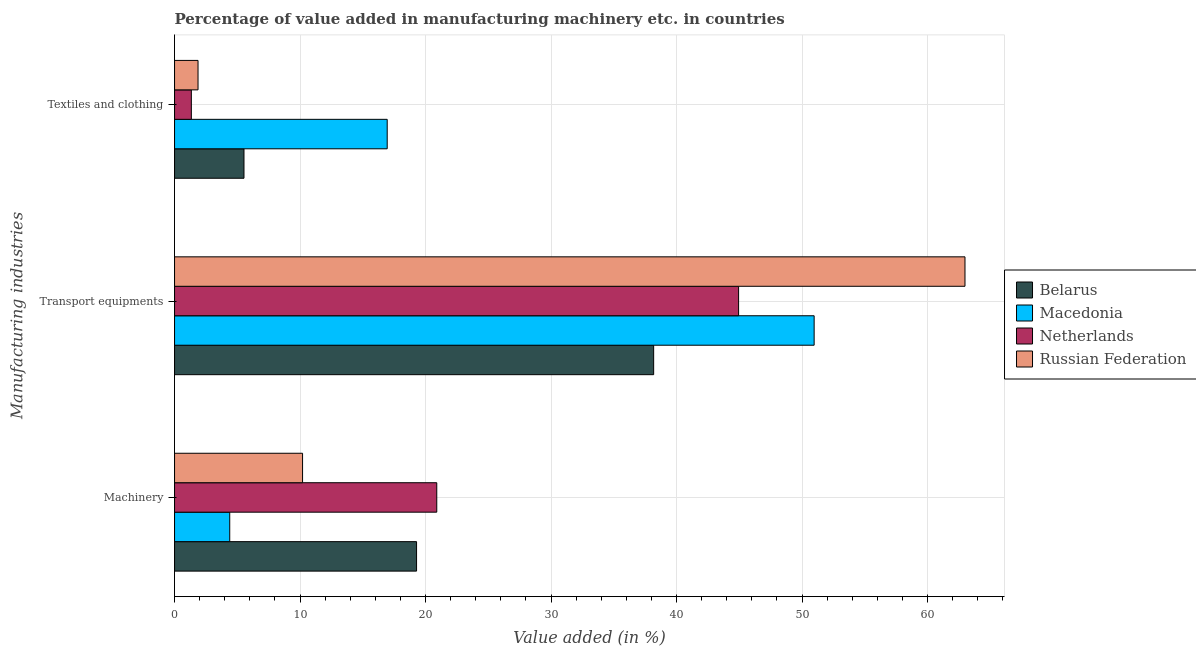How many groups of bars are there?
Your answer should be very brief. 3. Are the number of bars per tick equal to the number of legend labels?
Give a very brief answer. Yes. Are the number of bars on each tick of the Y-axis equal?
Your response must be concise. Yes. How many bars are there on the 1st tick from the top?
Provide a short and direct response. 4. What is the label of the 2nd group of bars from the top?
Offer a terse response. Transport equipments. What is the value added in manufacturing machinery in Netherlands?
Ensure brevity in your answer.  20.9. Across all countries, what is the maximum value added in manufacturing textile and clothing?
Make the answer very short. 16.95. Across all countries, what is the minimum value added in manufacturing textile and clothing?
Keep it short and to the point. 1.34. In which country was the value added in manufacturing transport equipments maximum?
Give a very brief answer. Russian Federation. In which country was the value added in manufacturing transport equipments minimum?
Your response must be concise. Belarus. What is the total value added in manufacturing transport equipments in the graph?
Provide a succinct answer. 197.08. What is the difference between the value added in manufacturing machinery in Belarus and that in Russian Federation?
Offer a very short reply. 9.08. What is the difference between the value added in manufacturing transport equipments in Belarus and the value added in manufacturing textile and clothing in Russian Federation?
Keep it short and to the point. 36.31. What is the average value added in manufacturing machinery per country?
Your answer should be compact. 13.7. What is the difference between the value added in manufacturing textile and clothing and value added in manufacturing machinery in Belarus?
Your answer should be very brief. -13.75. In how many countries, is the value added in manufacturing textile and clothing greater than 4 %?
Give a very brief answer. 2. What is the ratio of the value added in manufacturing textile and clothing in Macedonia to that in Russian Federation?
Your answer should be compact. 9.06. Is the value added in manufacturing machinery in Belarus less than that in Netherlands?
Keep it short and to the point. Yes. What is the difference between the highest and the second highest value added in manufacturing machinery?
Offer a very short reply. 1.61. What is the difference between the highest and the lowest value added in manufacturing transport equipments?
Provide a short and direct response. 24.81. In how many countries, is the value added in manufacturing transport equipments greater than the average value added in manufacturing transport equipments taken over all countries?
Offer a very short reply. 2. What does the 3rd bar from the top in Machinery represents?
Give a very brief answer. Macedonia. What does the 1st bar from the bottom in Textiles and clothing represents?
Provide a short and direct response. Belarus. Are all the bars in the graph horizontal?
Your answer should be very brief. Yes. Are the values on the major ticks of X-axis written in scientific E-notation?
Make the answer very short. No. Does the graph contain any zero values?
Offer a very short reply. No. Does the graph contain grids?
Provide a short and direct response. Yes. Where does the legend appear in the graph?
Give a very brief answer. Center right. How are the legend labels stacked?
Provide a short and direct response. Vertical. What is the title of the graph?
Offer a terse response. Percentage of value added in manufacturing machinery etc. in countries. Does "Libya" appear as one of the legend labels in the graph?
Make the answer very short. No. What is the label or title of the X-axis?
Provide a succinct answer. Value added (in %). What is the label or title of the Y-axis?
Ensure brevity in your answer.  Manufacturing industries. What is the Value added (in %) in Belarus in Machinery?
Ensure brevity in your answer.  19.29. What is the Value added (in %) in Macedonia in Machinery?
Give a very brief answer. 4.4. What is the Value added (in %) in Netherlands in Machinery?
Your response must be concise. 20.9. What is the Value added (in %) in Russian Federation in Machinery?
Ensure brevity in your answer.  10.2. What is the Value added (in %) of Belarus in Transport equipments?
Offer a terse response. 38.18. What is the Value added (in %) in Macedonia in Transport equipments?
Ensure brevity in your answer.  50.97. What is the Value added (in %) of Netherlands in Transport equipments?
Provide a succinct answer. 44.95. What is the Value added (in %) in Russian Federation in Transport equipments?
Your answer should be compact. 62.99. What is the Value added (in %) of Belarus in Textiles and clothing?
Offer a very short reply. 5.53. What is the Value added (in %) of Macedonia in Textiles and clothing?
Your response must be concise. 16.95. What is the Value added (in %) of Netherlands in Textiles and clothing?
Keep it short and to the point. 1.34. What is the Value added (in %) in Russian Federation in Textiles and clothing?
Keep it short and to the point. 1.87. Across all Manufacturing industries, what is the maximum Value added (in %) of Belarus?
Make the answer very short. 38.18. Across all Manufacturing industries, what is the maximum Value added (in %) in Macedonia?
Keep it short and to the point. 50.97. Across all Manufacturing industries, what is the maximum Value added (in %) in Netherlands?
Provide a succinct answer. 44.95. Across all Manufacturing industries, what is the maximum Value added (in %) in Russian Federation?
Ensure brevity in your answer.  62.99. Across all Manufacturing industries, what is the minimum Value added (in %) of Belarus?
Provide a short and direct response. 5.53. Across all Manufacturing industries, what is the minimum Value added (in %) in Macedonia?
Your response must be concise. 4.4. Across all Manufacturing industries, what is the minimum Value added (in %) of Netherlands?
Offer a terse response. 1.34. Across all Manufacturing industries, what is the minimum Value added (in %) of Russian Federation?
Give a very brief answer. 1.87. What is the total Value added (in %) in Belarus in the graph?
Your response must be concise. 63. What is the total Value added (in %) of Macedonia in the graph?
Offer a terse response. 72.31. What is the total Value added (in %) in Netherlands in the graph?
Offer a very short reply. 67.18. What is the total Value added (in %) in Russian Federation in the graph?
Give a very brief answer. 75.06. What is the difference between the Value added (in %) in Belarus in Machinery and that in Transport equipments?
Your answer should be very brief. -18.89. What is the difference between the Value added (in %) in Macedonia in Machinery and that in Transport equipments?
Ensure brevity in your answer.  -46.57. What is the difference between the Value added (in %) of Netherlands in Machinery and that in Transport equipments?
Make the answer very short. -24.05. What is the difference between the Value added (in %) in Russian Federation in Machinery and that in Transport equipments?
Provide a short and direct response. -52.79. What is the difference between the Value added (in %) in Belarus in Machinery and that in Textiles and clothing?
Your answer should be very brief. 13.75. What is the difference between the Value added (in %) of Macedonia in Machinery and that in Textiles and clothing?
Your answer should be compact. -12.55. What is the difference between the Value added (in %) in Netherlands in Machinery and that in Textiles and clothing?
Your response must be concise. 19.56. What is the difference between the Value added (in %) in Russian Federation in Machinery and that in Textiles and clothing?
Your answer should be very brief. 8.33. What is the difference between the Value added (in %) in Belarus in Transport equipments and that in Textiles and clothing?
Give a very brief answer. 32.65. What is the difference between the Value added (in %) of Macedonia in Transport equipments and that in Textiles and clothing?
Your response must be concise. 34.02. What is the difference between the Value added (in %) in Netherlands in Transport equipments and that in Textiles and clothing?
Make the answer very short. 43.61. What is the difference between the Value added (in %) of Russian Federation in Transport equipments and that in Textiles and clothing?
Offer a very short reply. 61.12. What is the difference between the Value added (in %) in Belarus in Machinery and the Value added (in %) in Macedonia in Transport equipments?
Offer a terse response. -31.68. What is the difference between the Value added (in %) of Belarus in Machinery and the Value added (in %) of Netherlands in Transport equipments?
Your answer should be very brief. -25.66. What is the difference between the Value added (in %) in Belarus in Machinery and the Value added (in %) in Russian Federation in Transport equipments?
Provide a short and direct response. -43.7. What is the difference between the Value added (in %) of Macedonia in Machinery and the Value added (in %) of Netherlands in Transport equipments?
Offer a very short reply. -40.55. What is the difference between the Value added (in %) in Macedonia in Machinery and the Value added (in %) in Russian Federation in Transport equipments?
Ensure brevity in your answer.  -58.59. What is the difference between the Value added (in %) of Netherlands in Machinery and the Value added (in %) of Russian Federation in Transport equipments?
Provide a short and direct response. -42.09. What is the difference between the Value added (in %) of Belarus in Machinery and the Value added (in %) of Macedonia in Textiles and clothing?
Provide a short and direct response. 2.34. What is the difference between the Value added (in %) in Belarus in Machinery and the Value added (in %) in Netherlands in Textiles and clothing?
Give a very brief answer. 17.95. What is the difference between the Value added (in %) of Belarus in Machinery and the Value added (in %) of Russian Federation in Textiles and clothing?
Your answer should be very brief. 17.41. What is the difference between the Value added (in %) in Macedonia in Machinery and the Value added (in %) in Netherlands in Textiles and clothing?
Your answer should be compact. 3.06. What is the difference between the Value added (in %) in Macedonia in Machinery and the Value added (in %) in Russian Federation in Textiles and clothing?
Provide a short and direct response. 2.53. What is the difference between the Value added (in %) of Netherlands in Machinery and the Value added (in %) of Russian Federation in Textiles and clothing?
Offer a very short reply. 19.02. What is the difference between the Value added (in %) of Belarus in Transport equipments and the Value added (in %) of Macedonia in Textiles and clothing?
Ensure brevity in your answer.  21.23. What is the difference between the Value added (in %) of Belarus in Transport equipments and the Value added (in %) of Netherlands in Textiles and clothing?
Offer a very short reply. 36.84. What is the difference between the Value added (in %) of Belarus in Transport equipments and the Value added (in %) of Russian Federation in Textiles and clothing?
Offer a terse response. 36.31. What is the difference between the Value added (in %) in Macedonia in Transport equipments and the Value added (in %) in Netherlands in Textiles and clothing?
Your response must be concise. 49.63. What is the difference between the Value added (in %) of Macedonia in Transport equipments and the Value added (in %) of Russian Federation in Textiles and clothing?
Ensure brevity in your answer.  49.1. What is the difference between the Value added (in %) of Netherlands in Transport equipments and the Value added (in %) of Russian Federation in Textiles and clothing?
Give a very brief answer. 43.08. What is the average Value added (in %) in Belarus per Manufacturing industries?
Your response must be concise. 21. What is the average Value added (in %) of Macedonia per Manufacturing industries?
Keep it short and to the point. 24.1. What is the average Value added (in %) of Netherlands per Manufacturing industries?
Provide a succinct answer. 22.39. What is the average Value added (in %) in Russian Federation per Manufacturing industries?
Your answer should be very brief. 25.02. What is the difference between the Value added (in %) in Belarus and Value added (in %) in Macedonia in Machinery?
Keep it short and to the point. 14.89. What is the difference between the Value added (in %) in Belarus and Value added (in %) in Netherlands in Machinery?
Your response must be concise. -1.61. What is the difference between the Value added (in %) of Belarus and Value added (in %) of Russian Federation in Machinery?
Your response must be concise. 9.08. What is the difference between the Value added (in %) of Macedonia and Value added (in %) of Netherlands in Machinery?
Your answer should be very brief. -16.5. What is the difference between the Value added (in %) in Macedonia and Value added (in %) in Russian Federation in Machinery?
Keep it short and to the point. -5.8. What is the difference between the Value added (in %) of Netherlands and Value added (in %) of Russian Federation in Machinery?
Offer a very short reply. 10.69. What is the difference between the Value added (in %) in Belarus and Value added (in %) in Macedonia in Transport equipments?
Your answer should be very brief. -12.79. What is the difference between the Value added (in %) in Belarus and Value added (in %) in Netherlands in Transport equipments?
Keep it short and to the point. -6.77. What is the difference between the Value added (in %) in Belarus and Value added (in %) in Russian Federation in Transport equipments?
Provide a succinct answer. -24.81. What is the difference between the Value added (in %) in Macedonia and Value added (in %) in Netherlands in Transport equipments?
Your response must be concise. 6.02. What is the difference between the Value added (in %) of Macedonia and Value added (in %) of Russian Federation in Transport equipments?
Your answer should be very brief. -12.02. What is the difference between the Value added (in %) in Netherlands and Value added (in %) in Russian Federation in Transport equipments?
Keep it short and to the point. -18.04. What is the difference between the Value added (in %) in Belarus and Value added (in %) in Macedonia in Textiles and clothing?
Provide a succinct answer. -11.41. What is the difference between the Value added (in %) of Belarus and Value added (in %) of Netherlands in Textiles and clothing?
Your answer should be compact. 4.2. What is the difference between the Value added (in %) of Belarus and Value added (in %) of Russian Federation in Textiles and clothing?
Your answer should be compact. 3.66. What is the difference between the Value added (in %) of Macedonia and Value added (in %) of Netherlands in Textiles and clothing?
Your response must be concise. 15.61. What is the difference between the Value added (in %) in Macedonia and Value added (in %) in Russian Federation in Textiles and clothing?
Offer a very short reply. 15.07. What is the difference between the Value added (in %) of Netherlands and Value added (in %) of Russian Federation in Textiles and clothing?
Provide a succinct answer. -0.53. What is the ratio of the Value added (in %) of Belarus in Machinery to that in Transport equipments?
Make the answer very short. 0.51. What is the ratio of the Value added (in %) of Macedonia in Machinery to that in Transport equipments?
Ensure brevity in your answer.  0.09. What is the ratio of the Value added (in %) in Netherlands in Machinery to that in Transport equipments?
Offer a terse response. 0.46. What is the ratio of the Value added (in %) in Russian Federation in Machinery to that in Transport equipments?
Give a very brief answer. 0.16. What is the ratio of the Value added (in %) in Belarus in Machinery to that in Textiles and clothing?
Give a very brief answer. 3.49. What is the ratio of the Value added (in %) of Macedonia in Machinery to that in Textiles and clothing?
Make the answer very short. 0.26. What is the ratio of the Value added (in %) in Netherlands in Machinery to that in Textiles and clothing?
Your response must be concise. 15.62. What is the ratio of the Value added (in %) in Russian Federation in Machinery to that in Textiles and clothing?
Offer a very short reply. 5.45. What is the ratio of the Value added (in %) of Belarus in Transport equipments to that in Textiles and clothing?
Offer a terse response. 6.9. What is the ratio of the Value added (in %) of Macedonia in Transport equipments to that in Textiles and clothing?
Make the answer very short. 3.01. What is the ratio of the Value added (in %) of Netherlands in Transport equipments to that in Textiles and clothing?
Keep it short and to the point. 33.59. What is the ratio of the Value added (in %) in Russian Federation in Transport equipments to that in Textiles and clothing?
Offer a terse response. 33.66. What is the difference between the highest and the second highest Value added (in %) of Belarus?
Provide a short and direct response. 18.89. What is the difference between the highest and the second highest Value added (in %) of Macedonia?
Ensure brevity in your answer.  34.02. What is the difference between the highest and the second highest Value added (in %) in Netherlands?
Make the answer very short. 24.05. What is the difference between the highest and the second highest Value added (in %) of Russian Federation?
Offer a terse response. 52.79. What is the difference between the highest and the lowest Value added (in %) of Belarus?
Your answer should be very brief. 32.65. What is the difference between the highest and the lowest Value added (in %) of Macedonia?
Ensure brevity in your answer.  46.57. What is the difference between the highest and the lowest Value added (in %) of Netherlands?
Your response must be concise. 43.61. What is the difference between the highest and the lowest Value added (in %) of Russian Federation?
Your response must be concise. 61.12. 